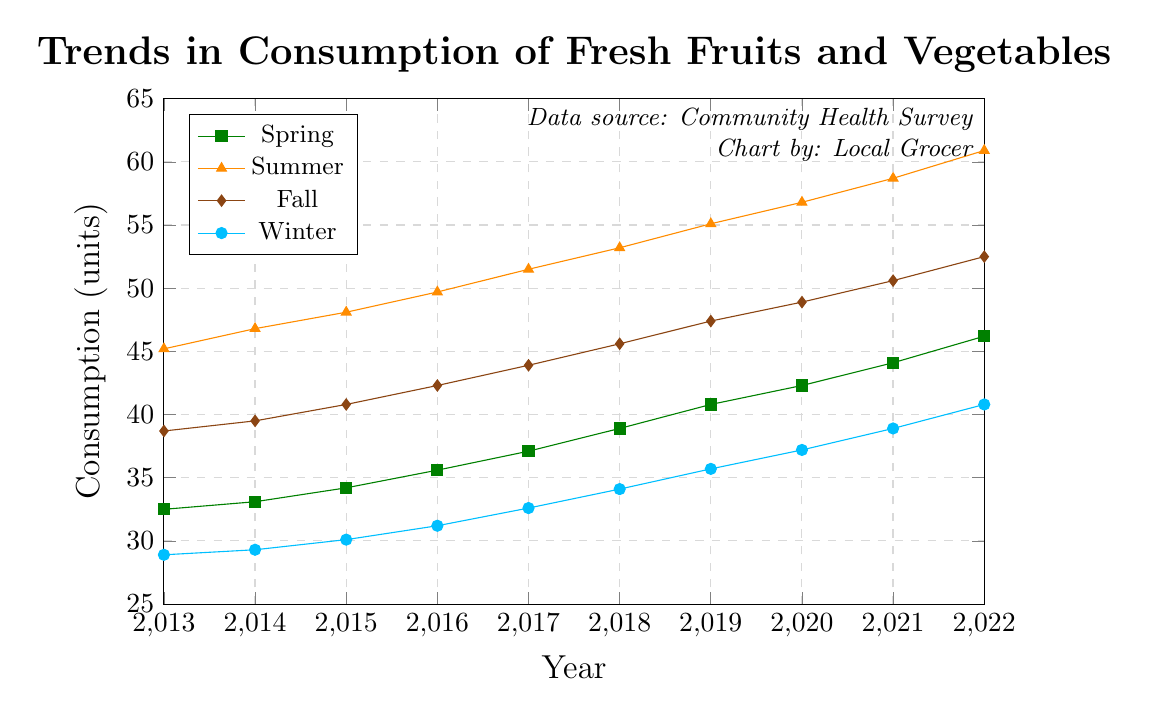Which season had the highest consumption in 2022? Look at the data points for 2022 and identify which season has the highest value. Summer has a value of 60.9, which is higher than Spring (46.2), Fall (52.5), and Winter (40.8).
Answer: Summer How much did the consumption increase from 2013 to 2022 in Spring? Subtract the consumption in 2013 from the consumption in 2022 for Spring: 46.2 - 32.5 = 13.7.
Answer: 13.7 Which season showed the greatest increase in consumption from 2013 to 2022? Calculate the difference between 2022 and 2013 for each season and compare: Spring (46.2 - 32.5 = 13.7), Summer (60.9 - 45.2 = 15.7), Fall (52.5 - 38.7 = 13.8), Winter (40.8 - 28.9 = 11.9). Summer shows the greatest increase of 15.7 units.
Answer: Summer What is the average consumption for Fall over the past decade? Add up the consumption values for Fall over all years and divide by the number of years: (38.7 + 39.5 + 40.8 + 42.3 + 43.9 + 45.6 + 47.4 + 48.9 + 50.6 + 52.5) / 10 = 45.02.
Answer: 45.02 In which year was the winter consumption closest to 30 units? Identify the Winter consumption values closest to 30 units: 29.3 in 2014 and 30.1 in 2015. Since 30.1 is closest to 30, the year is 2015.
Answer: 2015 Compare the trend in consumption for Summer and Winter. Which season's consumption increased more steadily? Look at the year-to-year increments for both Summer and Winter. Summer increases by approximately 1.6-1.9 units each year, while Winter increases by 0.8-1.6 units each year. Summer shows a more steady and higher increment.
Answer: Summer What is the total increase in consumption for all seasons from 2013 to 2022? Calculate the increase for each season and sum them: Spring (46.2 - 32.5 = 13.7), Summer (60.9 - 45.2 = 15.7), Fall (52.5 - 38.7 = 13.8), Winter (40.8 - 28.9 = 11.9). Total increase = 13.7 + 15.7 + 13.8 + 11.9 = 55.1.
Answer: 55.1 Which season had the smallest change in consumption between 2019 and 2020? Calculate the change for each season between 2019 and 2020: Spring (42.3 - 40.8 = 1.5), Summer (56.8 - 55.1 = 1.7), Fall (48.9 - 47.4 = 1.5), Winter (37.2 - 35.7 = 1.5). Spring, Fall, and Winter all had the smallest change of 1.5 units.
Answer: Spring, Fall, Winter 